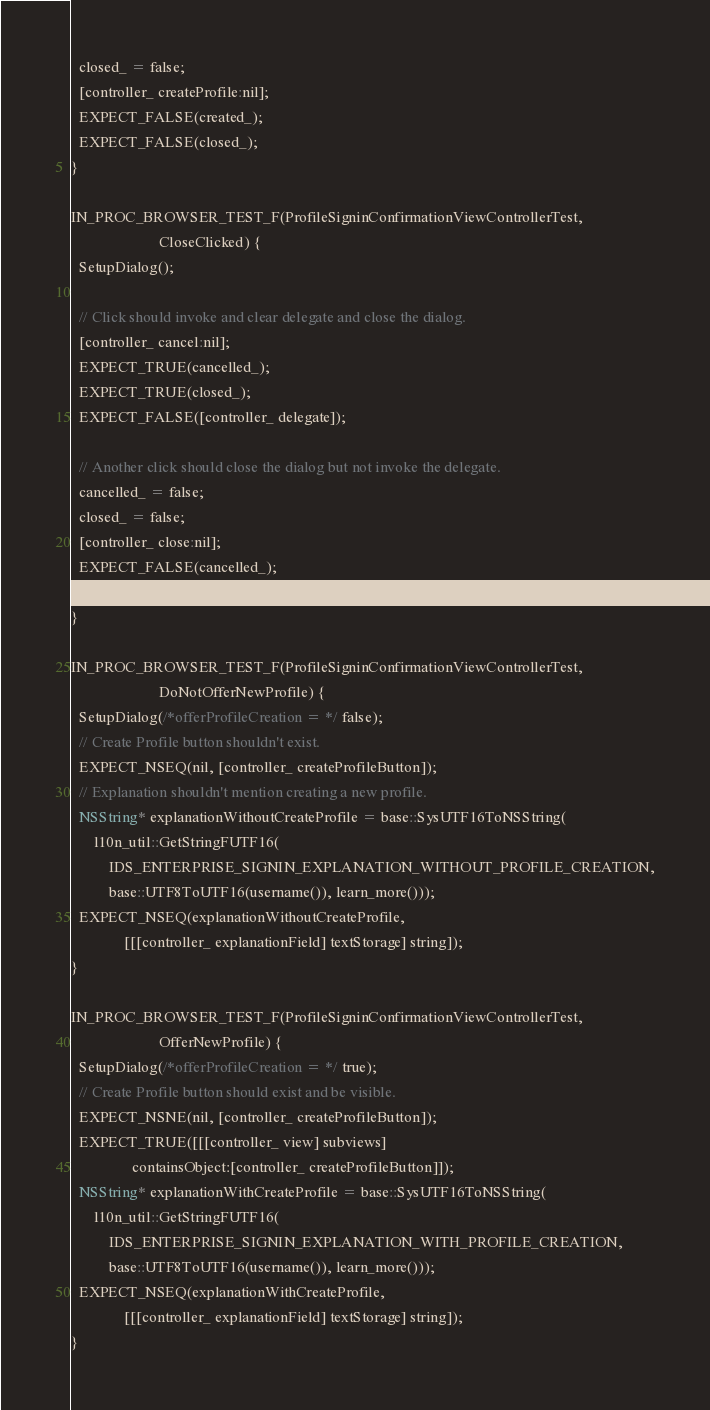<code> <loc_0><loc_0><loc_500><loc_500><_ObjectiveC_>  closed_ = false;
  [controller_ createProfile:nil];
  EXPECT_FALSE(created_);
  EXPECT_FALSE(closed_);
}

IN_PROC_BROWSER_TEST_F(ProfileSigninConfirmationViewControllerTest,
                       CloseClicked) {
  SetupDialog();

  // Click should invoke and clear delegate and close the dialog.
  [controller_ cancel:nil];
  EXPECT_TRUE(cancelled_);
  EXPECT_TRUE(closed_);
  EXPECT_FALSE([controller_ delegate]);

  // Another click should close the dialog but not invoke the delegate.
  cancelled_ = false;
  closed_ = false;
  [controller_ close:nil];
  EXPECT_FALSE(cancelled_);
  EXPECT_TRUE(closed_);
}

IN_PROC_BROWSER_TEST_F(ProfileSigninConfirmationViewControllerTest,
                       DoNotOfferNewProfile) {
  SetupDialog(/*offerProfileCreation = */ false);
  // Create Profile button shouldn't exist.
  EXPECT_NSEQ(nil, [controller_ createProfileButton]);
  // Explanation shouldn't mention creating a new profile.
  NSString* explanationWithoutCreateProfile = base::SysUTF16ToNSString(
      l10n_util::GetStringFUTF16(
          IDS_ENTERPRISE_SIGNIN_EXPLANATION_WITHOUT_PROFILE_CREATION,
          base::UTF8ToUTF16(username()), learn_more()));
  EXPECT_NSEQ(explanationWithoutCreateProfile,
              [[[controller_ explanationField] textStorage] string]);
}

IN_PROC_BROWSER_TEST_F(ProfileSigninConfirmationViewControllerTest,
                       OfferNewProfile) {
  SetupDialog(/*offerProfileCreation = */ true);
  // Create Profile button should exist and be visible.
  EXPECT_NSNE(nil, [controller_ createProfileButton]);
  EXPECT_TRUE([[[controller_ view] subviews]
                containsObject:[controller_ createProfileButton]]);
  NSString* explanationWithCreateProfile = base::SysUTF16ToNSString(
      l10n_util::GetStringFUTF16(
          IDS_ENTERPRISE_SIGNIN_EXPLANATION_WITH_PROFILE_CREATION,
          base::UTF8ToUTF16(username()), learn_more()));
  EXPECT_NSEQ(explanationWithCreateProfile,
              [[[controller_ explanationField] textStorage] string]);
}
</code> 